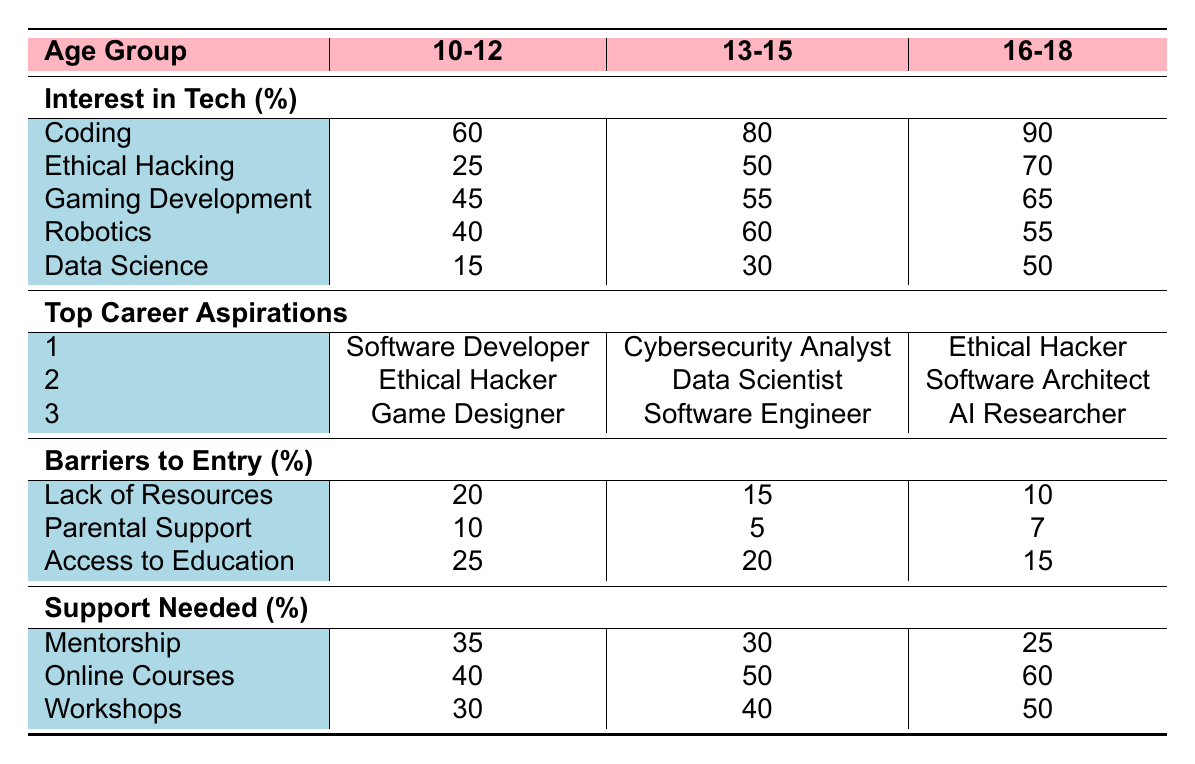What percentage of children aged 10-12 are interested in ethical hacking? Referring to the table under the "Interest in Tech (%)" section for the age group 10-12, ethical hacking is listed with a value of 25%.
Answer: 25% Which age group shows the highest interest in coding? The table lists the interest in coding for each age group: 10-12 (60%), 13-15 (80%), and 16-18 (90%). The highest percentage is 90% for the age group 16-18.
Answer: 16-18 What is the main barrier to entry for children aged 13-15? Looking at the "Barriers to Entry (%)" section for age group 13-15, the highest percentage is for access to education at 20%.
Answer: Access to education What support is most needed by the 10-12 age group? For the 10-12 age group, the support needed percentages are mentorship (35%), online courses (40%), and workshops (30%). The highest percentage is for online courses at 40%.
Answer: Online courses What is the combined interest in tech fields for children aged 16-18 (coding, ethical hacking, and data science)? The interests for age group 16-18 are coding (90%), ethical hacking (70%), and data science (50%). Adding these gives 90 + 70 + 50 = 210%.
Answer: 210% Is ethical hacking among the top three career aspirations for children aged 10-12? In the "Top Career Aspirations" section for age group 10-12, ethical hacking is listed second, confirming it is among the top three aspirations.
Answer: Yes What is the difference in interest in robotics between children aged 10-12 and those aged 13-15? The interest in robotics for 10-12 is 40% and for 13-15 is 60%. The difference is 60% - 40% = 20%.
Answer: 20% Which age group requires the least parental support according to the table? Under the "Barriers to Entry (%)" section, parental support for the age groups are 10% (10-12), 5% (13-15), and 7% (16-18). The least support needed is 5% for age group 13-15.
Answer: 13-15 What percentage of children aged 16-18 are interested in gaming development? Referring to the table, the interest in gaming development for the age group 16-18 is 65%.
Answer: 65% Do children aged 13-15 have more interest in ethical hacking or data science? The table shows that 50% of 13-15 year-olds are interested in ethical hacking and 30% in data science, indicating that they have more interest in ethical hacking.
Answer: Ethical hacking 